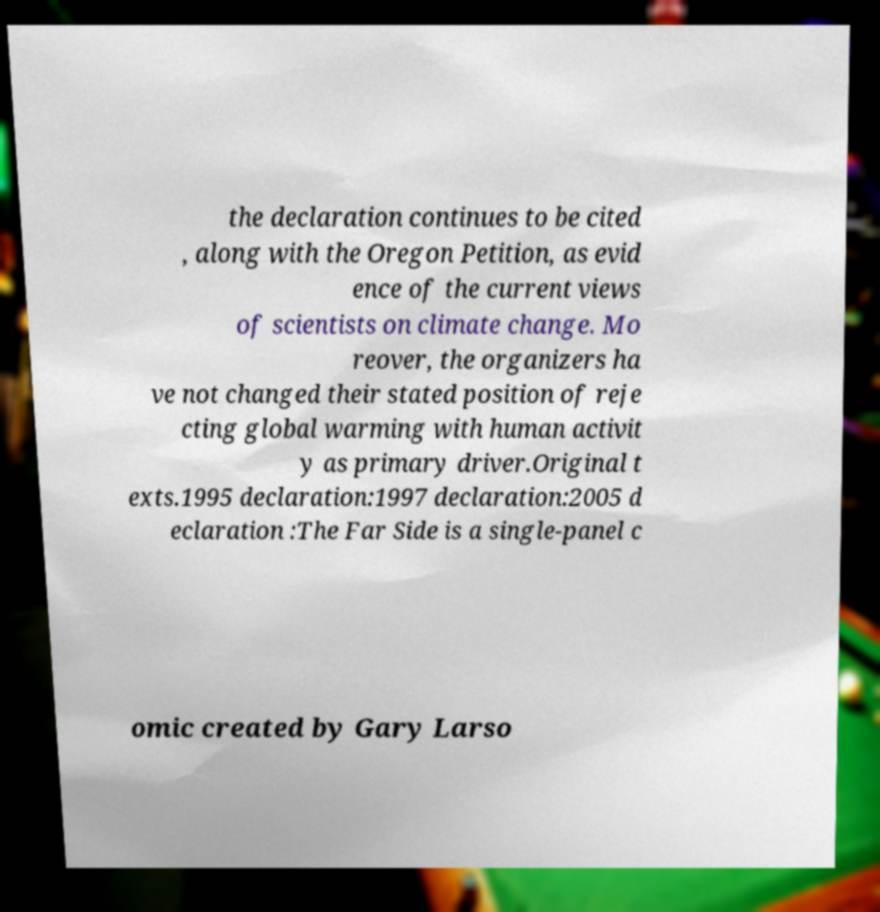Please read and relay the text visible in this image. What does it say? the declaration continues to be cited , along with the Oregon Petition, as evid ence of the current views of scientists on climate change. Mo reover, the organizers ha ve not changed their stated position of reje cting global warming with human activit y as primary driver.Original t exts.1995 declaration:1997 declaration:2005 d eclaration :The Far Side is a single-panel c omic created by Gary Larso 